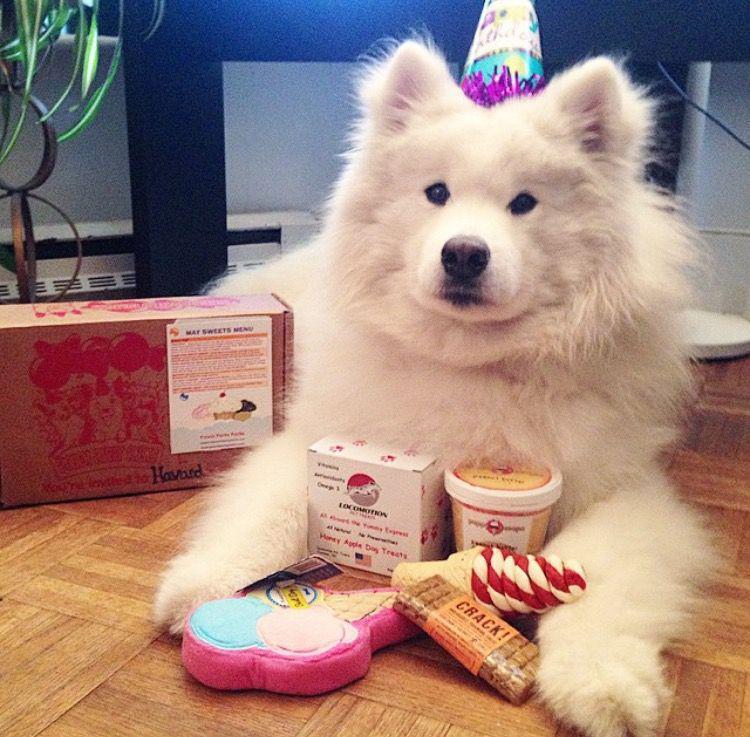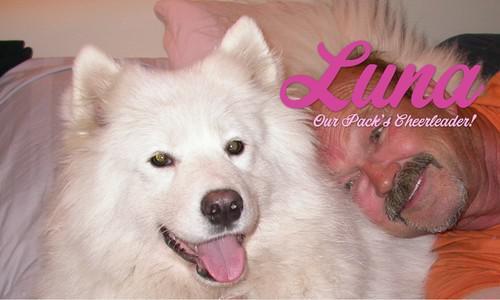The first image is the image on the left, the second image is the image on the right. Evaluate the accuracy of this statement regarding the images: "There are two dogs in total.". Is it true? Answer yes or no. Yes. The first image is the image on the left, the second image is the image on the right. Assess this claim about the two images: "An image shows a white dog with something edible in front of him.". Correct or not? Answer yes or no. Yes. 